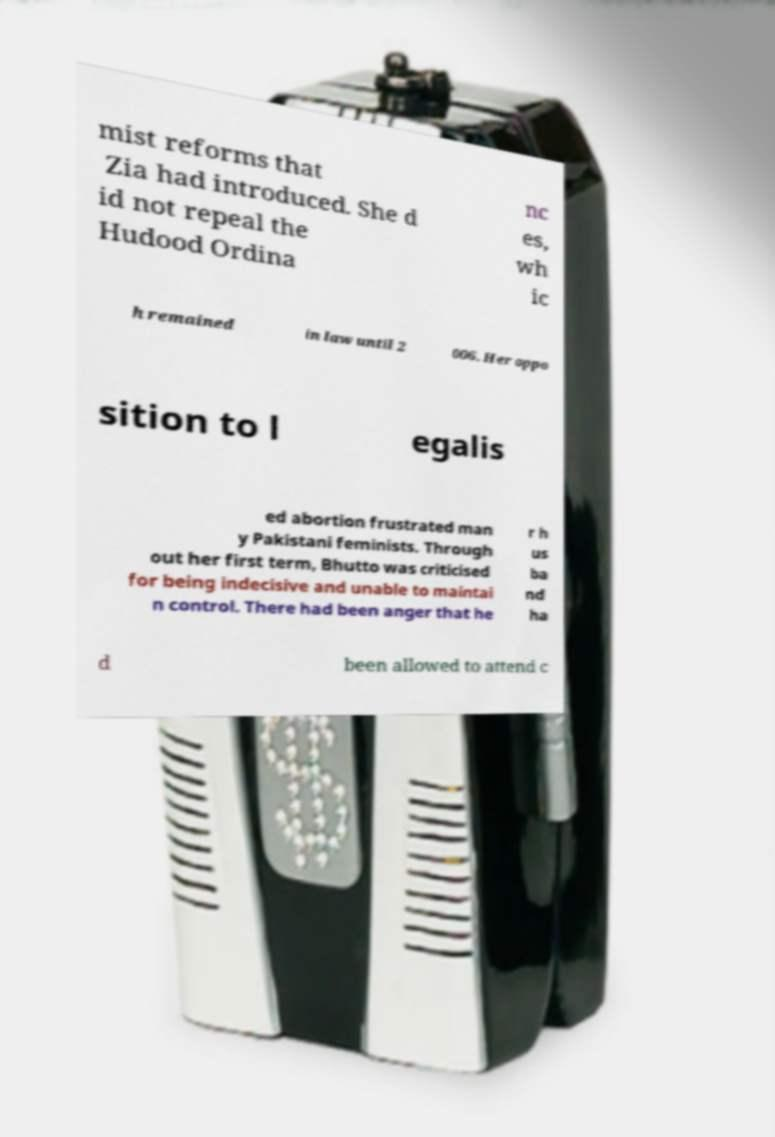What messages or text are displayed in this image? I need them in a readable, typed format. mist reforms that Zia had introduced. She d id not repeal the Hudood Ordina nc es, wh ic h remained in law until 2 006. Her oppo sition to l egalis ed abortion frustrated man y Pakistani feminists. Through out her first term, Bhutto was criticised for being indecisive and unable to maintai n control. There had been anger that he r h us ba nd ha d been allowed to attend c 